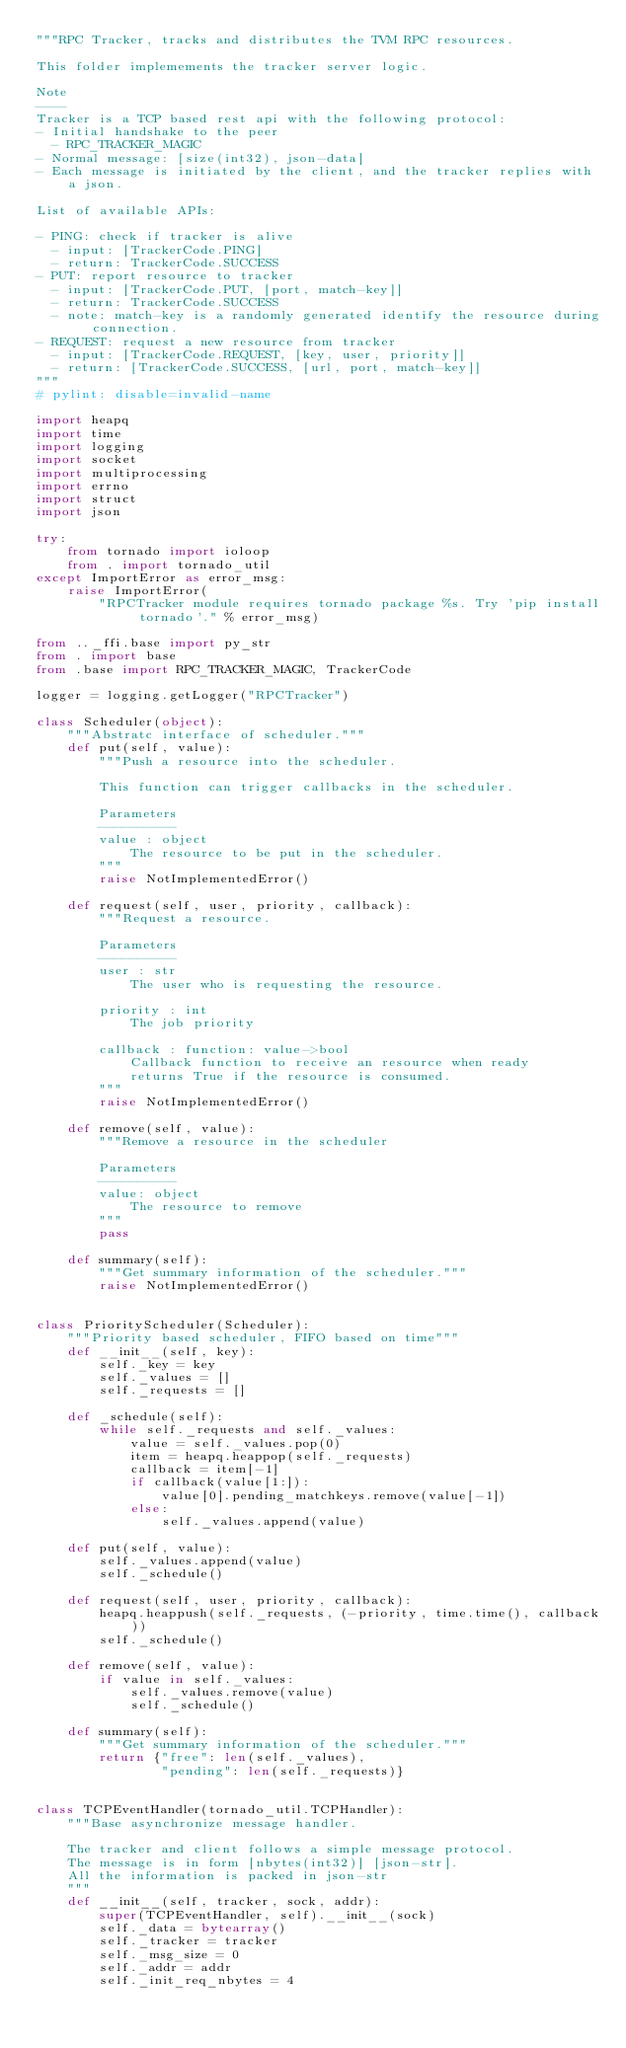Convert code to text. <code><loc_0><loc_0><loc_500><loc_500><_Python_>"""RPC Tracker, tracks and distributes the TVM RPC resources.

This folder implemements the tracker server logic.

Note
----
Tracker is a TCP based rest api with the following protocol:
- Initial handshake to the peer
  - RPC_TRACKER_MAGIC
- Normal message: [size(int32), json-data]
- Each message is initiated by the client, and the tracker replies with a json.

List of available APIs:

- PING: check if tracker is alive
  - input: [TrackerCode.PING]
  - return: TrackerCode.SUCCESS
- PUT: report resource to tracker
  - input: [TrackerCode.PUT, [port, match-key]]
  - return: TrackerCode.SUCCESS
  - note: match-key is a randomly generated identify the resource during connection.
- REQUEST: request a new resource from tracker
  - input: [TrackerCode.REQUEST, [key, user, priority]]
  - return: [TrackerCode.SUCCESS, [url, port, match-key]]
"""
# pylint: disable=invalid-name

import heapq
import time
import logging
import socket
import multiprocessing
import errno
import struct
import json

try:
    from tornado import ioloop
    from . import tornado_util
except ImportError as error_msg:
    raise ImportError(
        "RPCTracker module requires tornado package %s. Try 'pip install tornado'." % error_msg)

from .._ffi.base import py_str
from . import base
from .base import RPC_TRACKER_MAGIC, TrackerCode

logger = logging.getLogger("RPCTracker")

class Scheduler(object):
    """Abstratc interface of scheduler."""
    def put(self, value):
        """Push a resource into the scheduler.

        This function can trigger callbacks in the scheduler.

        Parameters
        ----------
        value : object
            The resource to be put in the scheduler.
        """
        raise NotImplementedError()

    def request(self, user, priority, callback):
        """Request a resource.

        Parameters
        ----------
        user : str
            The user who is requesting the resource.

        priority : int
            The job priority

        callback : function: value->bool
            Callback function to receive an resource when ready
            returns True if the resource is consumed.
        """
        raise NotImplementedError()

    def remove(self, value):
        """Remove a resource in the scheduler

        Parameters
        ----------
        value: object
            The resource to remove
        """
        pass

    def summary(self):
        """Get summary information of the scheduler."""
        raise NotImplementedError()


class PriorityScheduler(Scheduler):
    """Priority based scheduler, FIFO based on time"""
    def __init__(self, key):
        self._key = key
        self._values = []
        self._requests = []

    def _schedule(self):
        while self._requests and self._values:
            value = self._values.pop(0)
            item = heapq.heappop(self._requests)
            callback = item[-1]
            if callback(value[1:]):
                value[0].pending_matchkeys.remove(value[-1])
            else:
                self._values.append(value)

    def put(self, value):
        self._values.append(value)
        self._schedule()

    def request(self, user, priority, callback):
        heapq.heappush(self._requests, (-priority, time.time(), callback))
        self._schedule()

    def remove(self, value):
        if value in self._values:
            self._values.remove(value)
            self._schedule()

    def summary(self):
        """Get summary information of the scheduler."""
        return {"free": len(self._values),
                "pending": len(self._requests)}


class TCPEventHandler(tornado_util.TCPHandler):
    """Base asynchronize message handler.

    The tracker and client follows a simple message protocol.
    The message is in form [nbytes(int32)] [json-str].
    All the information is packed in json-str
    """
    def __init__(self, tracker, sock, addr):
        super(TCPEventHandler, self).__init__(sock)
        self._data = bytearray()
        self._tracker = tracker
        self._msg_size = 0
        self._addr = addr
        self._init_req_nbytes = 4</code> 